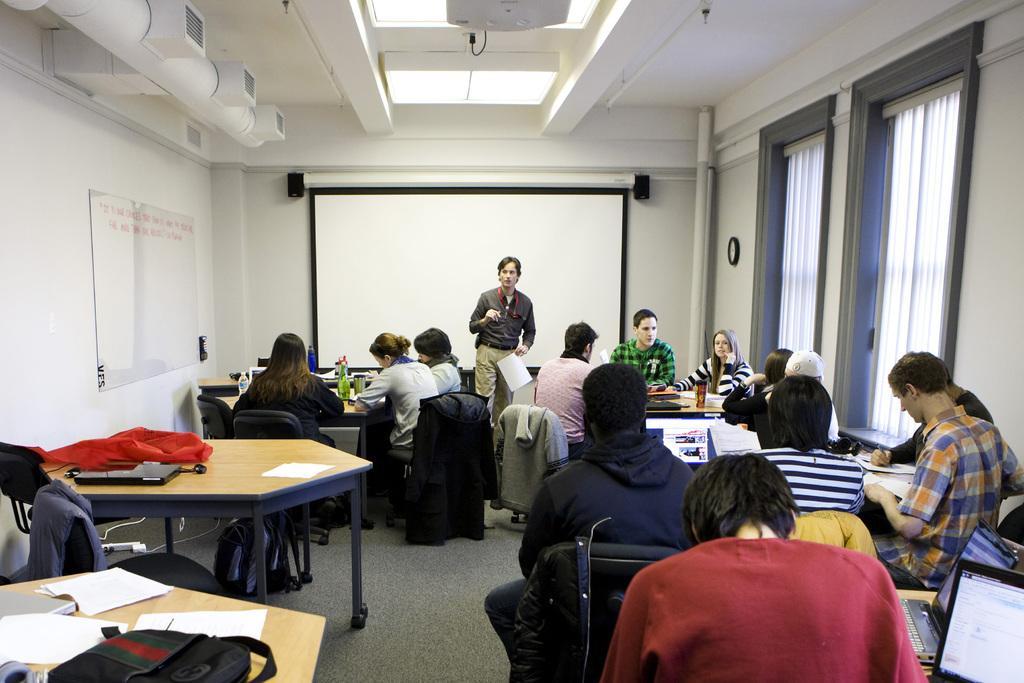Could you give a brief overview of what you see in this image? This is an image clicked inside the room. In this I can see some tables and chairs around it. There are some people sitting on the chairs and doing some paper work. In the background I can see a screen, in front of this screen there is a person standing and holding a paper in his hand. On the tables there are some papers, bags are there. On the right side I can see two windows and having white color curtains. 